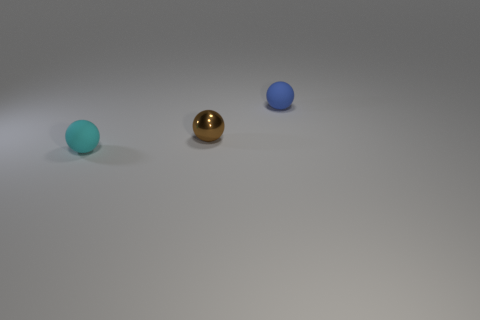Add 2 small things. How many objects exist? 5 Subtract 0 gray balls. How many objects are left? 3 Subtract all large green matte cylinders. Subtract all shiny objects. How many objects are left? 2 Add 1 matte spheres. How many matte spheres are left? 3 Add 3 brown metallic objects. How many brown metallic objects exist? 4 